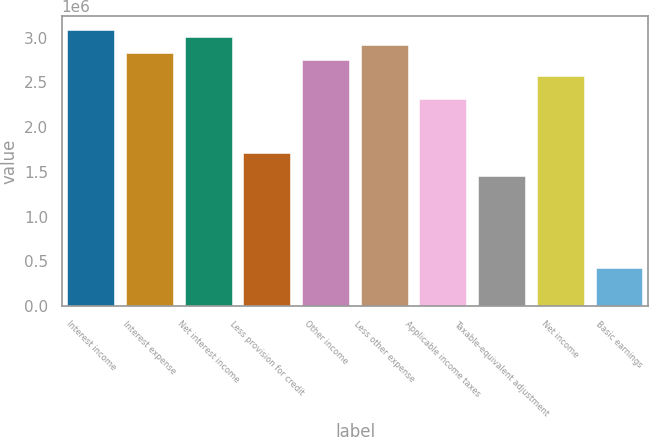Convert chart to OTSL. <chart><loc_0><loc_0><loc_500><loc_500><bar_chart><fcel>Interest income<fcel>Interest expense<fcel>Net interest income<fcel>Less provision for credit<fcel>Other income<fcel>Less other expense<fcel>Applicable income taxes<fcel>Taxable-equivalent adjustment<fcel>Net income<fcel>Basic earnings<nl><fcel>3.08883e+06<fcel>2.83143e+06<fcel>3.00303e+06<fcel>1.71602e+06<fcel>2.74562e+06<fcel>2.91723e+06<fcel>2.31662e+06<fcel>1.45861e+06<fcel>2.57402e+06<fcel>429004<nl></chart> 